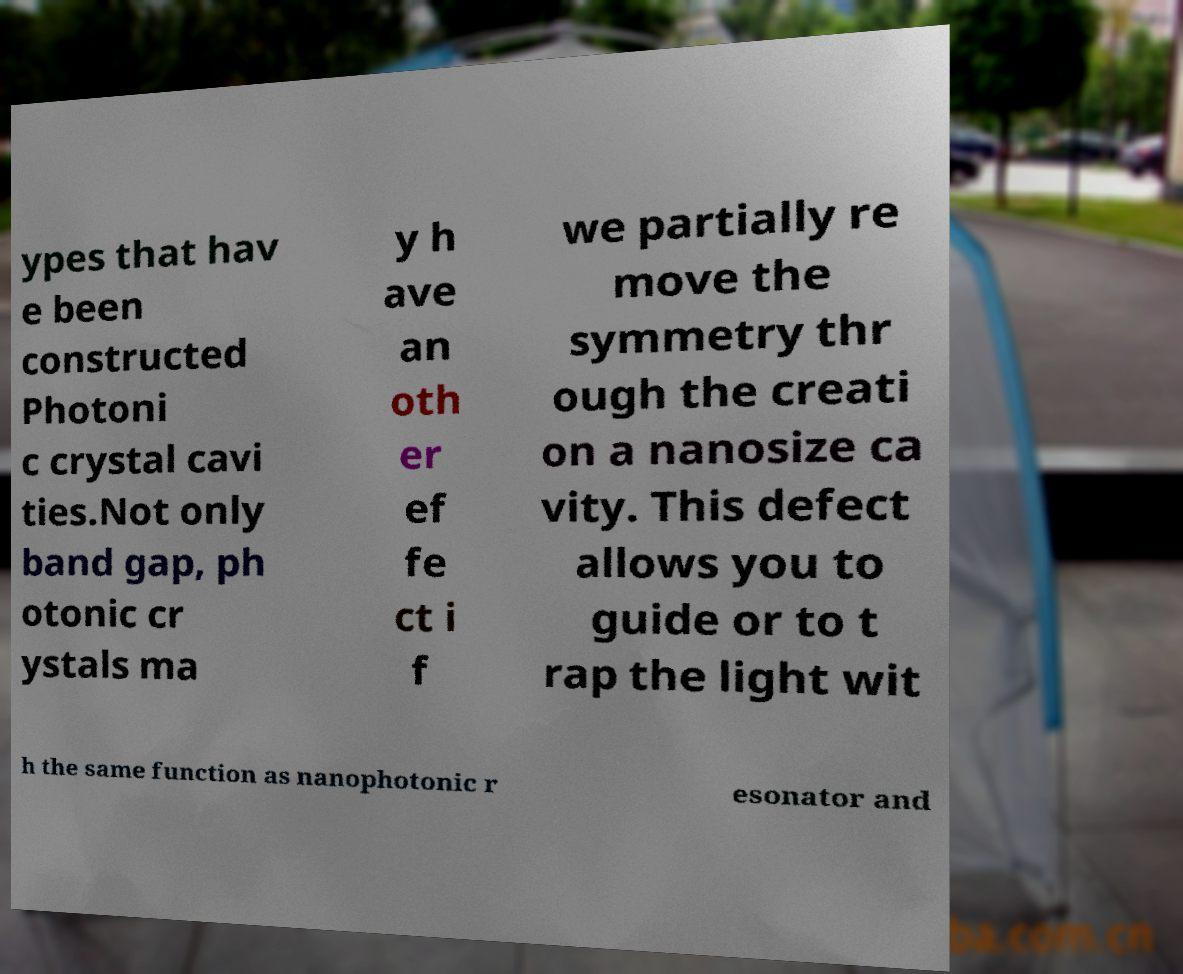I need the written content from this picture converted into text. Can you do that? ypes that hav e been constructed Photoni c crystal cavi ties.Not only band gap, ph otonic cr ystals ma y h ave an oth er ef fe ct i f we partially re move the symmetry thr ough the creati on a nanosize ca vity. This defect allows you to guide or to t rap the light wit h the same function as nanophotonic r esonator and 